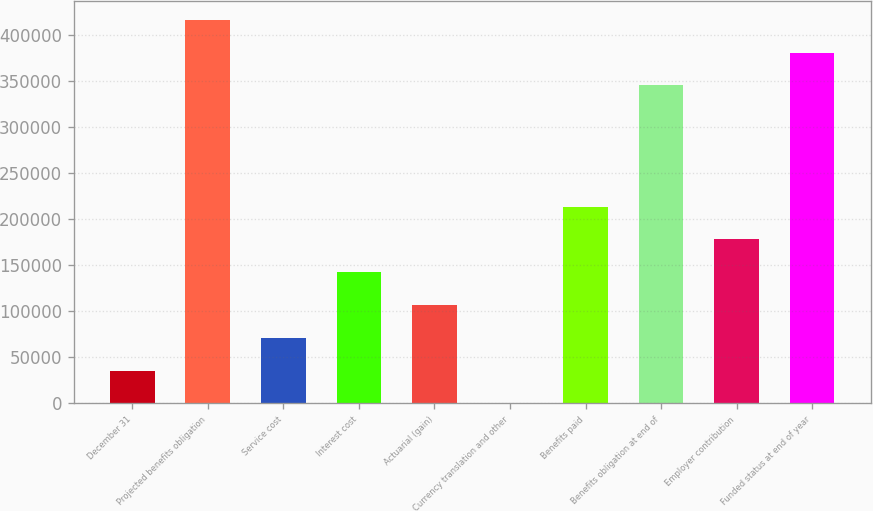<chart> <loc_0><loc_0><loc_500><loc_500><bar_chart><fcel>December 31<fcel>Projected benefits obligation<fcel>Service cost<fcel>Interest cost<fcel>Actuarial (gain)<fcel>Currency translation and other<fcel>Benefits paid<fcel>Benefits obligation at end of<fcel>Employer contribution<fcel>Funded status at end of year<nl><fcel>35632.8<fcel>416282<fcel>71215.6<fcel>142381<fcel>106798<fcel>50<fcel>213547<fcel>345116<fcel>177964<fcel>380699<nl></chart> 